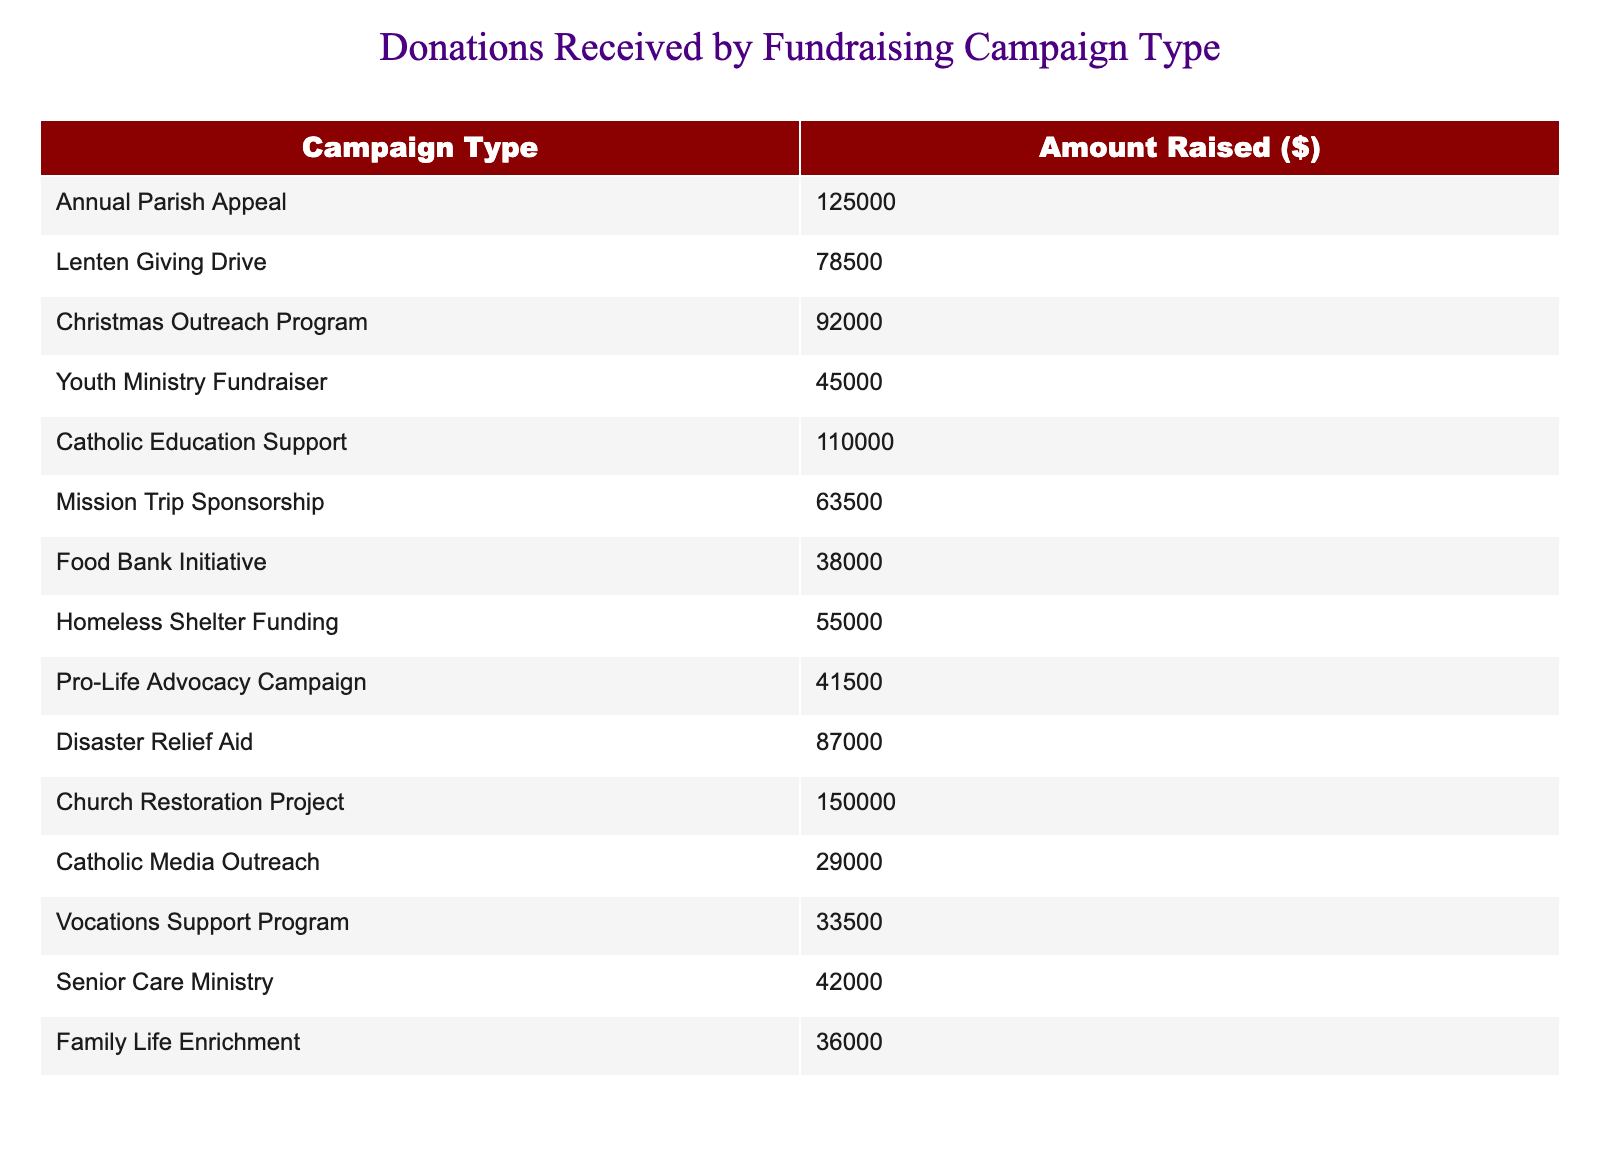What was the amount raised in the Christmas Outreach Program? The table shows the amount raised specifically for the Christmas Outreach Program listed as $92,000.
Answer: 92000 Which fundraising campaign type raised the least amount of money? By comparing the amounts raised for each campaign, the Food Bank Initiative raised the least at $38,000.
Answer: Food Bank Initiative What is the total amount raised by the top three fundraising campaigns? The top three fundraising campaigns are the Church Restoration Project ($150,000), Catholic Education Support ($110,000), and Annual Parish Appeal ($125,000). The total is $150,000 + $110,000 + $125,000 = $385,000.
Answer: 385000 Did the Lenten Giving Drive raise more than the Pro-Life Advocacy Campaign? The Lenten Giving Drive raised $78,500 and the Pro-Life Advocacy Campaign raised $41,500. Since $78,500 is greater than $41,500, therefore the statement is true.
Answer: Yes What is the average amount raised by all fundraising campaigns? First, we sum all the amounts raised: $125,000 + $78,500 + $92,000 + $45,000 + $110,000 + $63,500 + $38,000 + $55,000 + $41,500 + $87,000 + $150,000 + $29,000 + $33,500 + $42,000 + $36,000 = $1,063,500. There are 15 campaigns, so the average is $1,063,500 / 15 = $71,567.
Answer: 71567 Which campaign types combined raised more than $200,000? The Church Restoration Project ($150,000) and Catholic Education Support ($110,000) combined raise $150,000 + $110,000 = $260,000. This amount exceeds $200,000.
Answer: Church Restoration Project and Catholic Education Support 